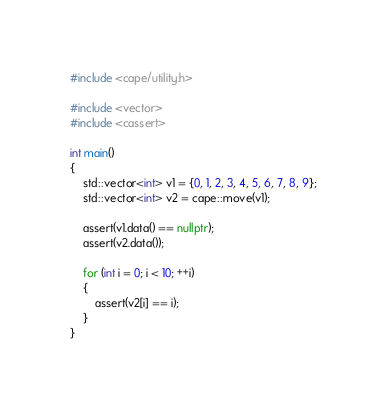Convert code to text. <code><loc_0><loc_0><loc_500><loc_500><_C++_>#include <cape/utility.h>

#include <vector>
#include <cassert>

int main()
{
	std::vector<int> v1 = {0, 1, 2, 3, 4, 5, 6, 7, 8, 9};
	std::vector<int> v2 = cape::move(v1);

	assert(v1.data() == nullptr);
	assert(v2.data());

	for (int i = 0; i < 10; ++i)
	{
		assert(v2[i] == i);
	}
}
</code> 